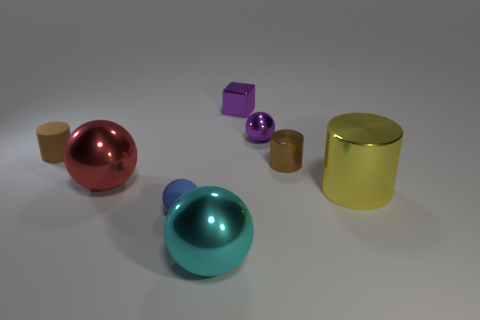The object that is the same color as the cube is what shape?
Offer a very short reply. Sphere. There is a small rubber object in front of the yellow cylinder; is it the same color as the large sphere that is on the left side of the blue matte object?
Your answer should be very brief. No. What number of metal objects are in front of the small matte cylinder and to the right of the red metal thing?
Keep it short and to the point. 3. What material is the cyan ball?
Provide a short and direct response. Metal. There is a red metal thing that is the same size as the cyan sphere; what is its shape?
Your answer should be very brief. Sphere. Is the material of the big ball behind the big yellow shiny cylinder the same as the small brown thing that is in front of the rubber cylinder?
Offer a terse response. Yes. What number of tiny things are there?
Ensure brevity in your answer.  5. How many small brown things have the same shape as the large yellow object?
Your answer should be very brief. 2. Is the large cyan object the same shape as the small brown rubber thing?
Keep it short and to the point. No. The purple shiny cube has what size?
Your answer should be very brief. Small. 